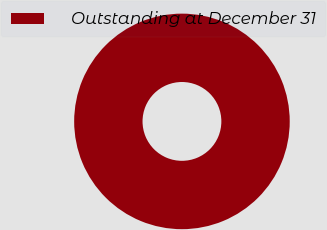Convert chart to OTSL. <chart><loc_0><loc_0><loc_500><loc_500><pie_chart><fcel>Outstanding at December 31<nl><fcel>100.0%<nl></chart> 